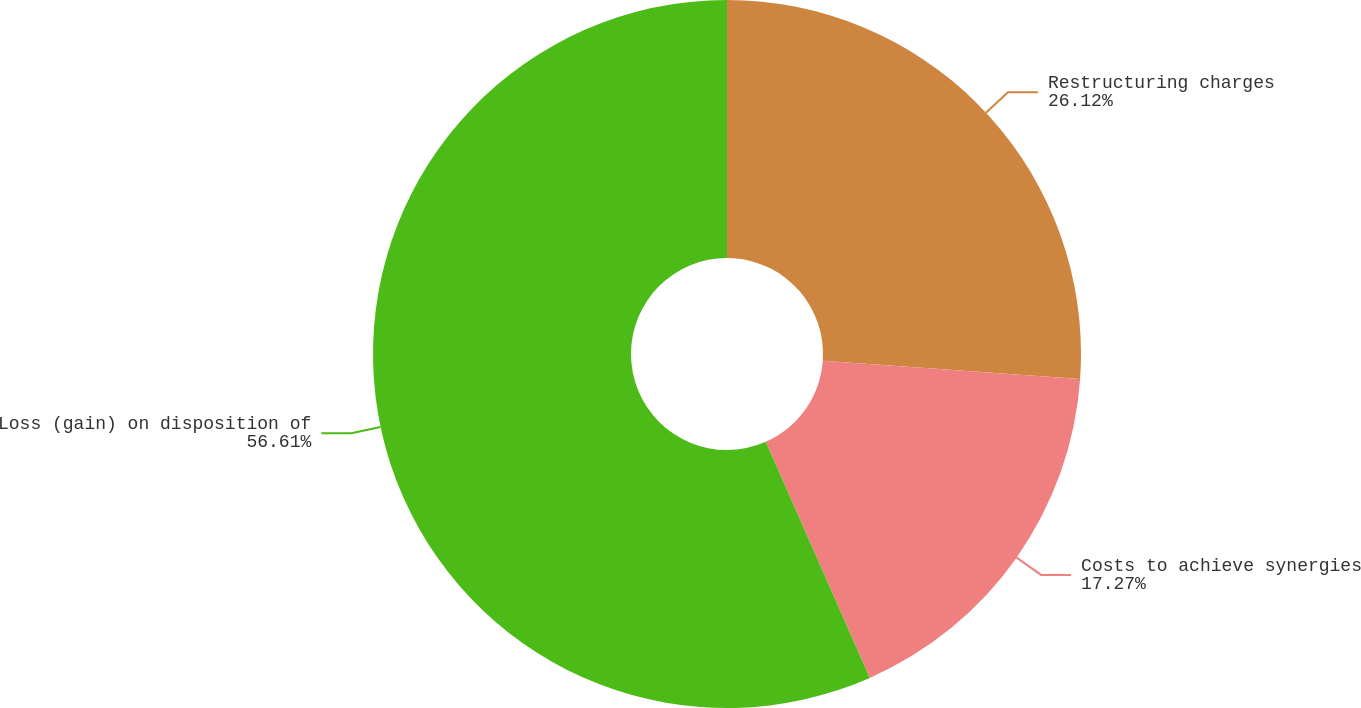Convert chart. <chart><loc_0><loc_0><loc_500><loc_500><pie_chart><fcel>Restructuring charges<fcel>Costs to achieve synergies<fcel>Loss (gain) on disposition of<nl><fcel>26.12%<fcel>17.27%<fcel>56.61%<nl></chart> 